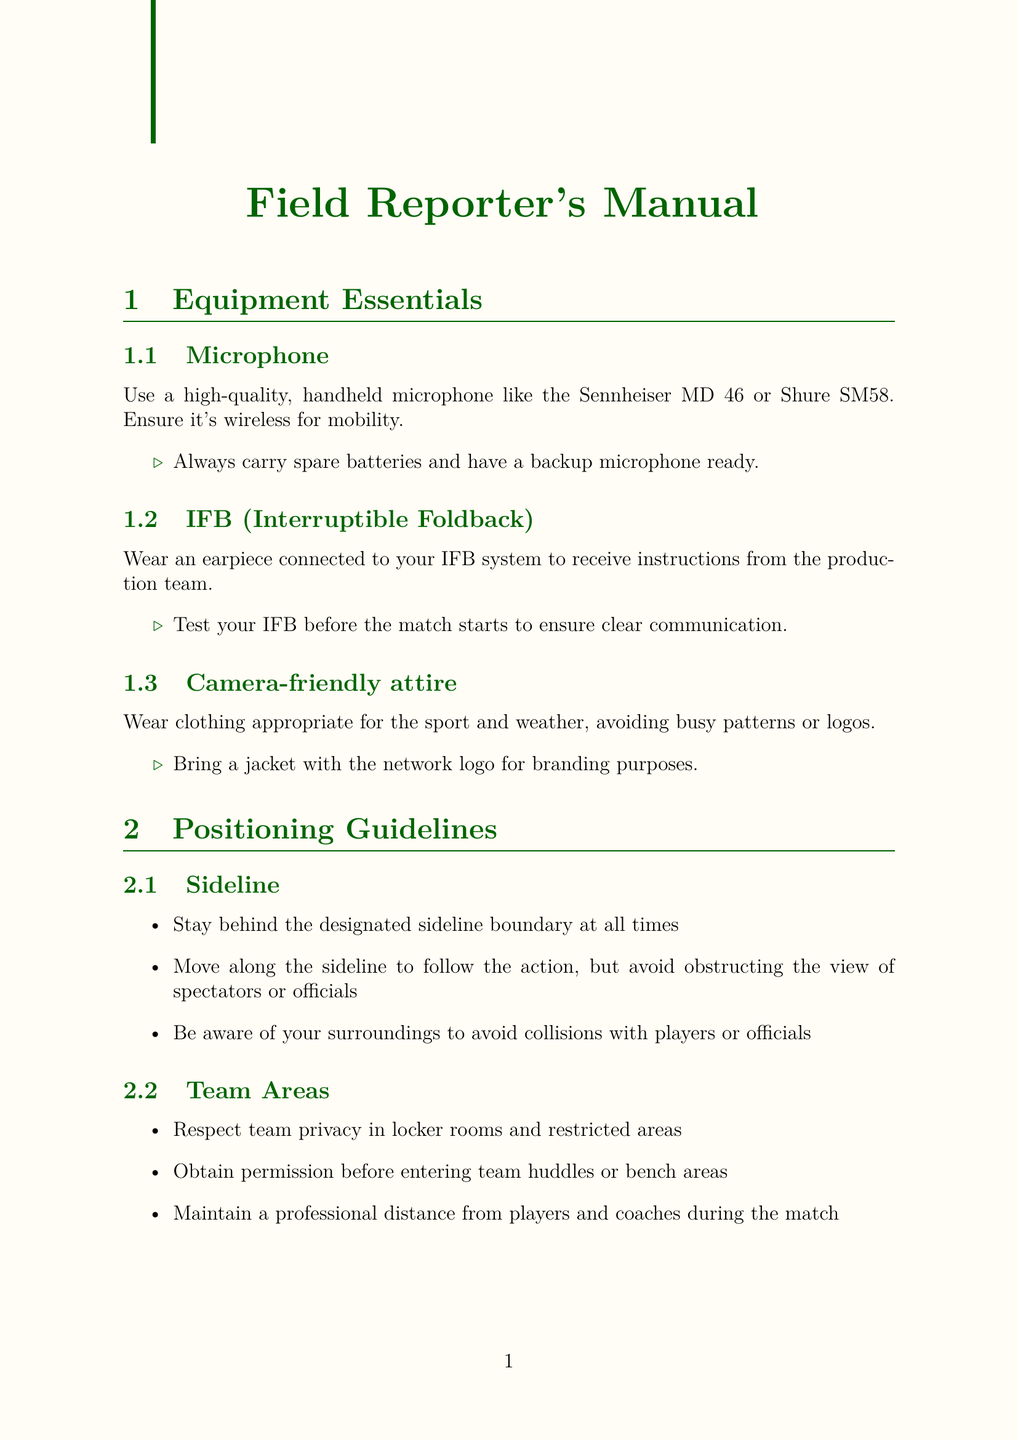what type of microphone is recommended? The document specifies a high-quality, handheld microphone like the Sennheiser MD 46 or Shure SM58.
Answer: Sennheiser MD 46 or Shure SM58 what should you carry as a backup for the microphone? The manual advises always carrying spare batteries and having a backup microphone ready.
Answer: Spare batteries and a backup microphone where should you position yourself for post-match interviews? The guidelines indicate that you should position yourself in the designated mixed zone or interview area.
Answer: Designated mixed zone or interview area what is the main guideline for sideline positioning? The document states that you should stay behind the designated sideline boundary at all times.
Answer: Stay behind the designated sideline boundary what should be done in the case of uncooperative interviewees? The document suggests respecting their right to decline an interview.
Answer: Respect their right to decline an interview how should one test their IFB before the match? The manual mentions testing your IFB before the match starts to ensure clear communication.
Answer: Test your IFB before the match starts what should be avoided in camera-friendly attire? The guidelines advise avoiding busy patterns or logos.
Answer: Busy patterns or logos what actions should be taken during technical difficulties? It is recommended to remain calm and professional on camera, among other actions.
Answer: Remain calm and professional on camera 